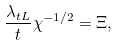<formula> <loc_0><loc_0><loc_500><loc_500>\frac { \lambda _ { t L } } { t } \chi ^ { - 1 / 2 } = \Xi ,</formula> 